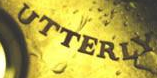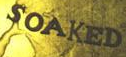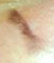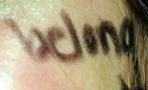Read the text content from these images in order, separated by a semicolon. UTTERLY; SOAKED; I; belong 